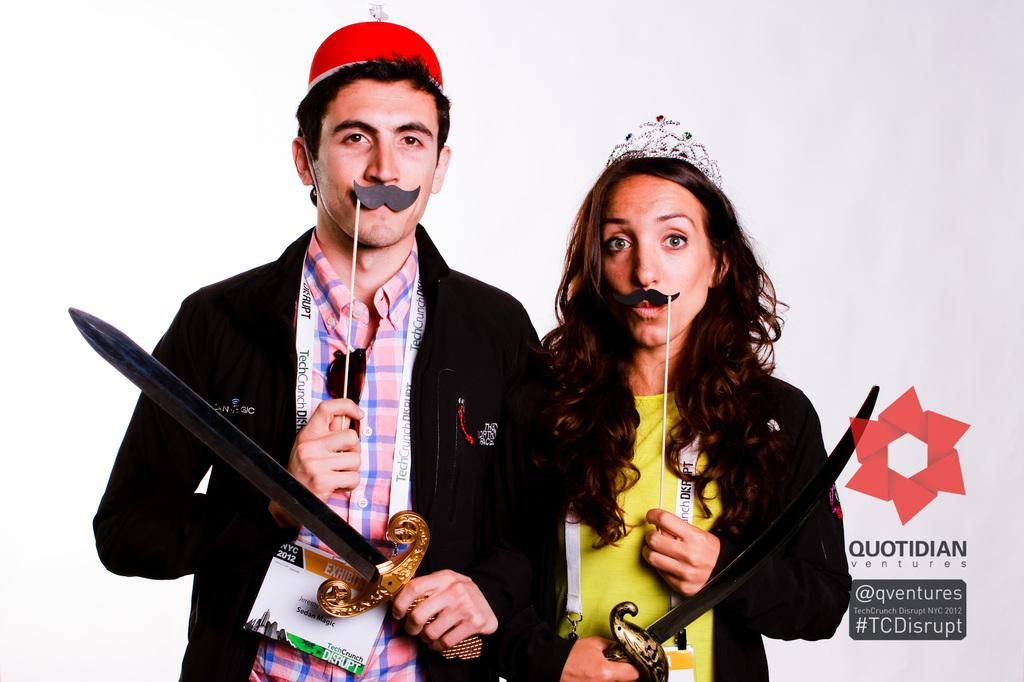How many people are present in the image? There are two people in the image, a man and a woman. What are the man and woman holding in the image? Both the man and woman are holding swords in the image. Can you describe the man's attire? The man is wearing a cap in the image. What can be seen on the right side of the image? There is a logo on the right side of the image, along with some text associated with the logo. What type of smoke is coming out of the oven in the image? There is no oven or smoke present in the image. 